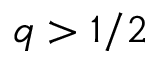Convert formula to latex. <formula><loc_0><loc_0><loc_500><loc_500>q > 1 / 2</formula> 